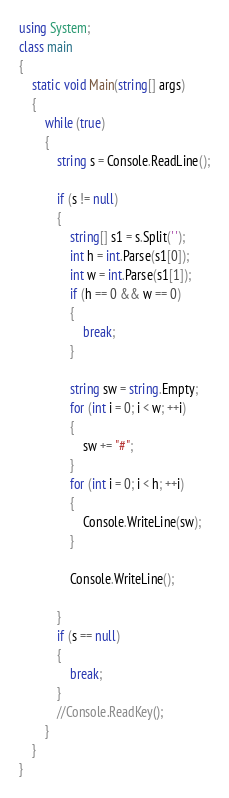Convert code to text. <code><loc_0><loc_0><loc_500><loc_500><_C#_>using System;
class main
{
    static void Main(string[] args)
    {
        while (true)
        {
            string s = Console.ReadLine();

            if (s != null)
            {
                string[] s1 = s.Split(' ');
                int h = int.Parse(s1[0]);
                int w = int.Parse(s1[1]);
                if (h == 0 && w == 0)
                {
                    break;
                }

                string sw = string.Empty;
                for (int i = 0; i < w; ++i)
                {
                    sw += "#";
                }
                for (int i = 0; i < h; ++i)
                {
                    Console.WriteLine(sw);
                }

                Console.WriteLine();

            }
            if (s == null)
            {
                break;
            }
            //Console.ReadKey();
        }
    }
}</code> 